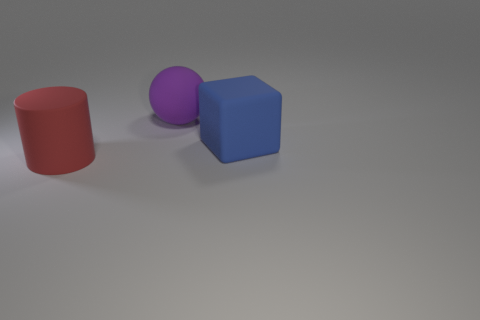Imagine these objects are part of a computer graphics course. What topic could they be illustrating? These objects could exemplify a variety of topics in a computer graphics course. They might be used to demonstrate 3D modeling, shading techniques, light and shadow interplay, as well as the rendering of different textures and materials to achieve realistic visuals within the software. 